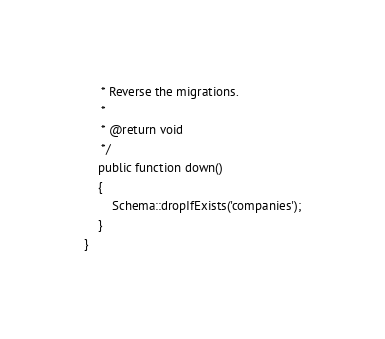<code> <loc_0><loc_0><loc_500><loc_500><_PHP_>     * Reverse the migrations.
     *
     * @return void
     */
    public function down()
    {
        Schema::dropIfExists('companies');
    }
}
</code> 